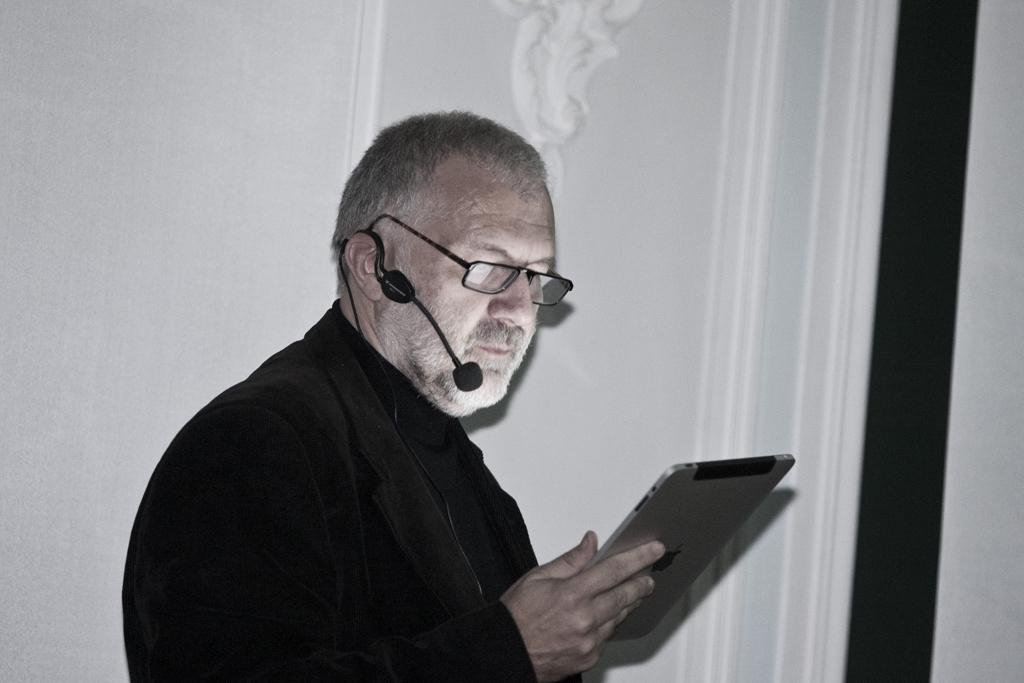In one or two sentences, can you explain what this image depicts? In the middle of the image a man is standing and holding a tab and looking in to it. Behind him there is a wall. 